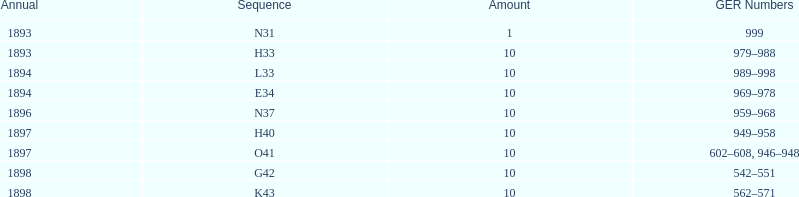When was g42, 1898 or 1894? 1898. 